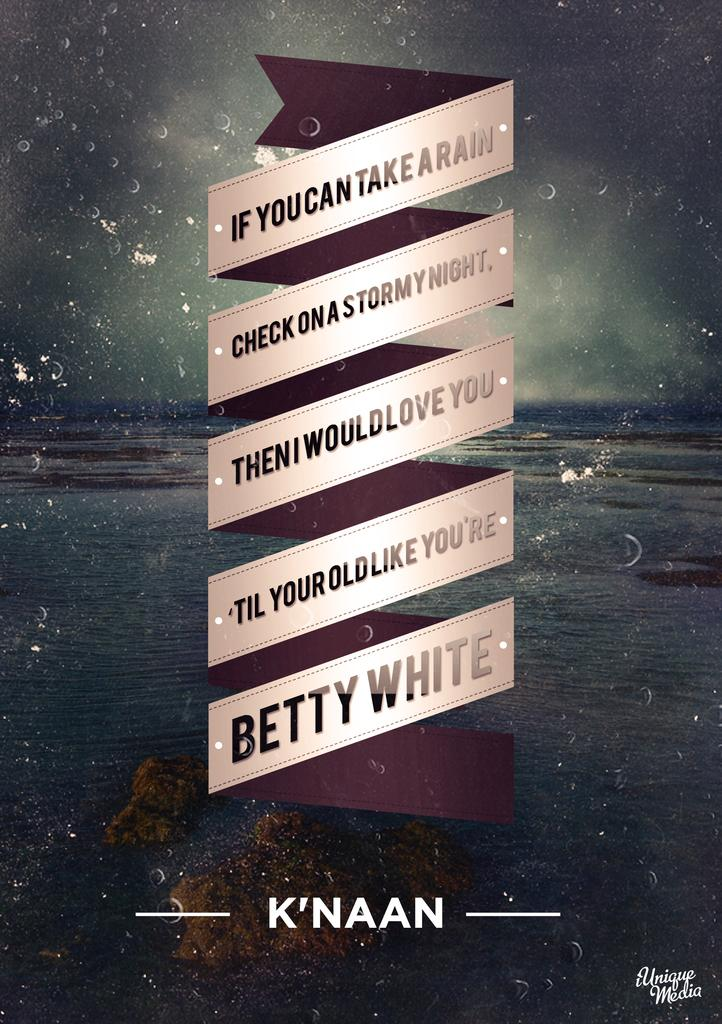<image>
Provide a brief description of the given image. A poster with a saying about the rain written by Betty White 